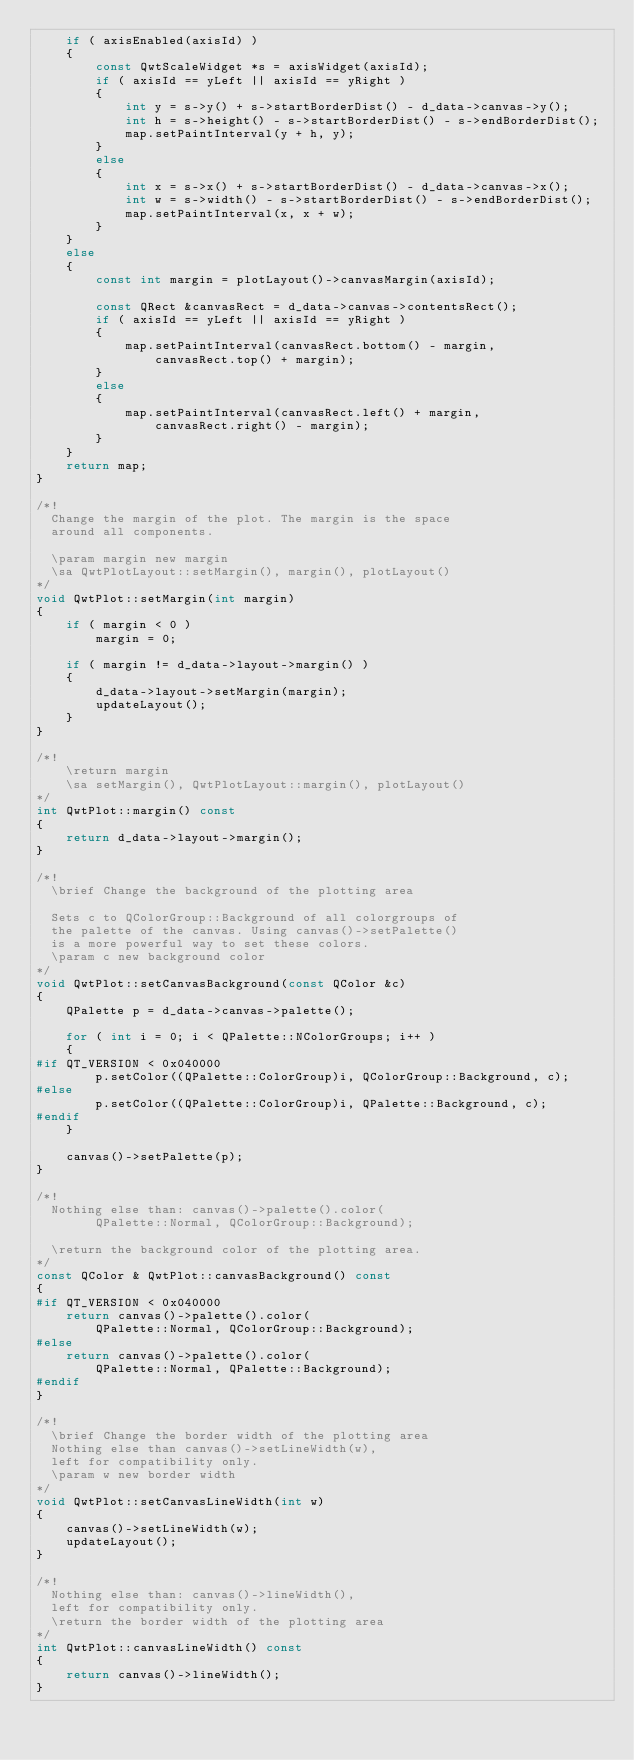Convert code to text. <code><loc_0><loc_0><loc_500><loc_500><_C++_>    if ( axisEnabled(axisId) )
    {
        const QwtScaleWidget *s = axisWidget(axisId);
        if ( axisId == yLeft || axisId == yRight )
        {
            int y = s->y() + s->startBorderDist() - d_data->canvas->y();
            int h = s->height() - s->startBorderDist() - s->endBorderDist();
            map.setPaintInterval(y + h, y);
        }
        else
        {
            int x = s->x() + s->startBorderDist() - d_data->canvas->x();
            int w = s->width() - s->startBorderDist() - s->endBorderDist();
            map.setPaintInterval(x, x + w);
        }
    }
    else
    {
        const int margin = plotLayout()->canvasMargin(axisId);

        const QRect &canvasRect = d_data->canvas->contentsRect();
        if ( axisId == yLeft || axisId == yRight )
        {
            map.setPaintInterval(canvasRect.bottom() - margin, 
                canvasRect.top() + margin);
        }
        else
        {
            map.setPaintInterval(canvasRect.left() + margin, 
                canvasRect.right() - margin);
        }
    }
    return map;
}

/*!
  Change the margin of the plot. The margin is the space
  around all components.

  \param margin new margin
  \sa QwtPlotLayout::setMargin(), margin(), plotLayout()
*/
void QwtPlot::setMargin(int margin)
{
    if ( margin < 0 )
        margin = 0;

    if ( margin != d_data->layout->margin() )
    {
        d_data->layout->setMargin(margin);
        updateLayout();
    }
}

/*!
    \return margin
    \sa setMargin(), QwtPlotLayout::margin(), plotLayout()
*/
int QwtPlot::margin() const
{
    return d_data->layout->margin();
}

/*!
  \brief Change the background of the plotting area
  
  Sets c to QColorGroup::Background of all colorgroups of 
  the palette of the canvas. Using canvas()->setPalette()
  is a more powerful way to set these colors.
  \param c new background color
*/
void QwtPlot::setCanvasBackground(const QColor &c)
{
    QPalette p = d_data->canvas->palette();

    for ( int i = 0; i < QPalette::NColorGroups; i++ )
    {
#if QT_VERSION < 0x040000
        p.setColor((QPalette::ColorGroup)i, QColorGroup::Background, c);
#else
        p.setColor((QPalette::ColorGroup)i, QPalette::Background, c);
#endif
    }

    canvas()->setPalette(p);
}

/*!
  Nothing else than: canvas()->palette().color(
        QPalette::Normal, QColorGroup::Background);
  
  \return the background color of the plotting area.
*/
const QColor & QwtPlot::canvasBackground() const
{
#if QT_VERSION < 0x040000
    return canvas()->palette().color(
        QPalette::Normal, QColorGroup::Background);
#else
    return canvas()->palette().color(
        QPalette::Normal, QPalette::Background);
#endif
}

/*!
  \brief Change the border width of the plotting area
  Nothing else than canvas()->setLineWidth(w), 
  left for compatibility only.
  \param w new border width
*/
void QwtPlot::setCanvasLineWidth(int w)
{
    canvas()->setLineWidth(w);
    updateLayout();
}
 
/*! 
  Nothing else than: canvas()->lineWidth(), 
  left for compatibility only.
  \return the border width of the plotting area
*/
int QwtPlot::canvasLineWidth() const
{ 
    return canvas()->lineWidth();
}
</code> 